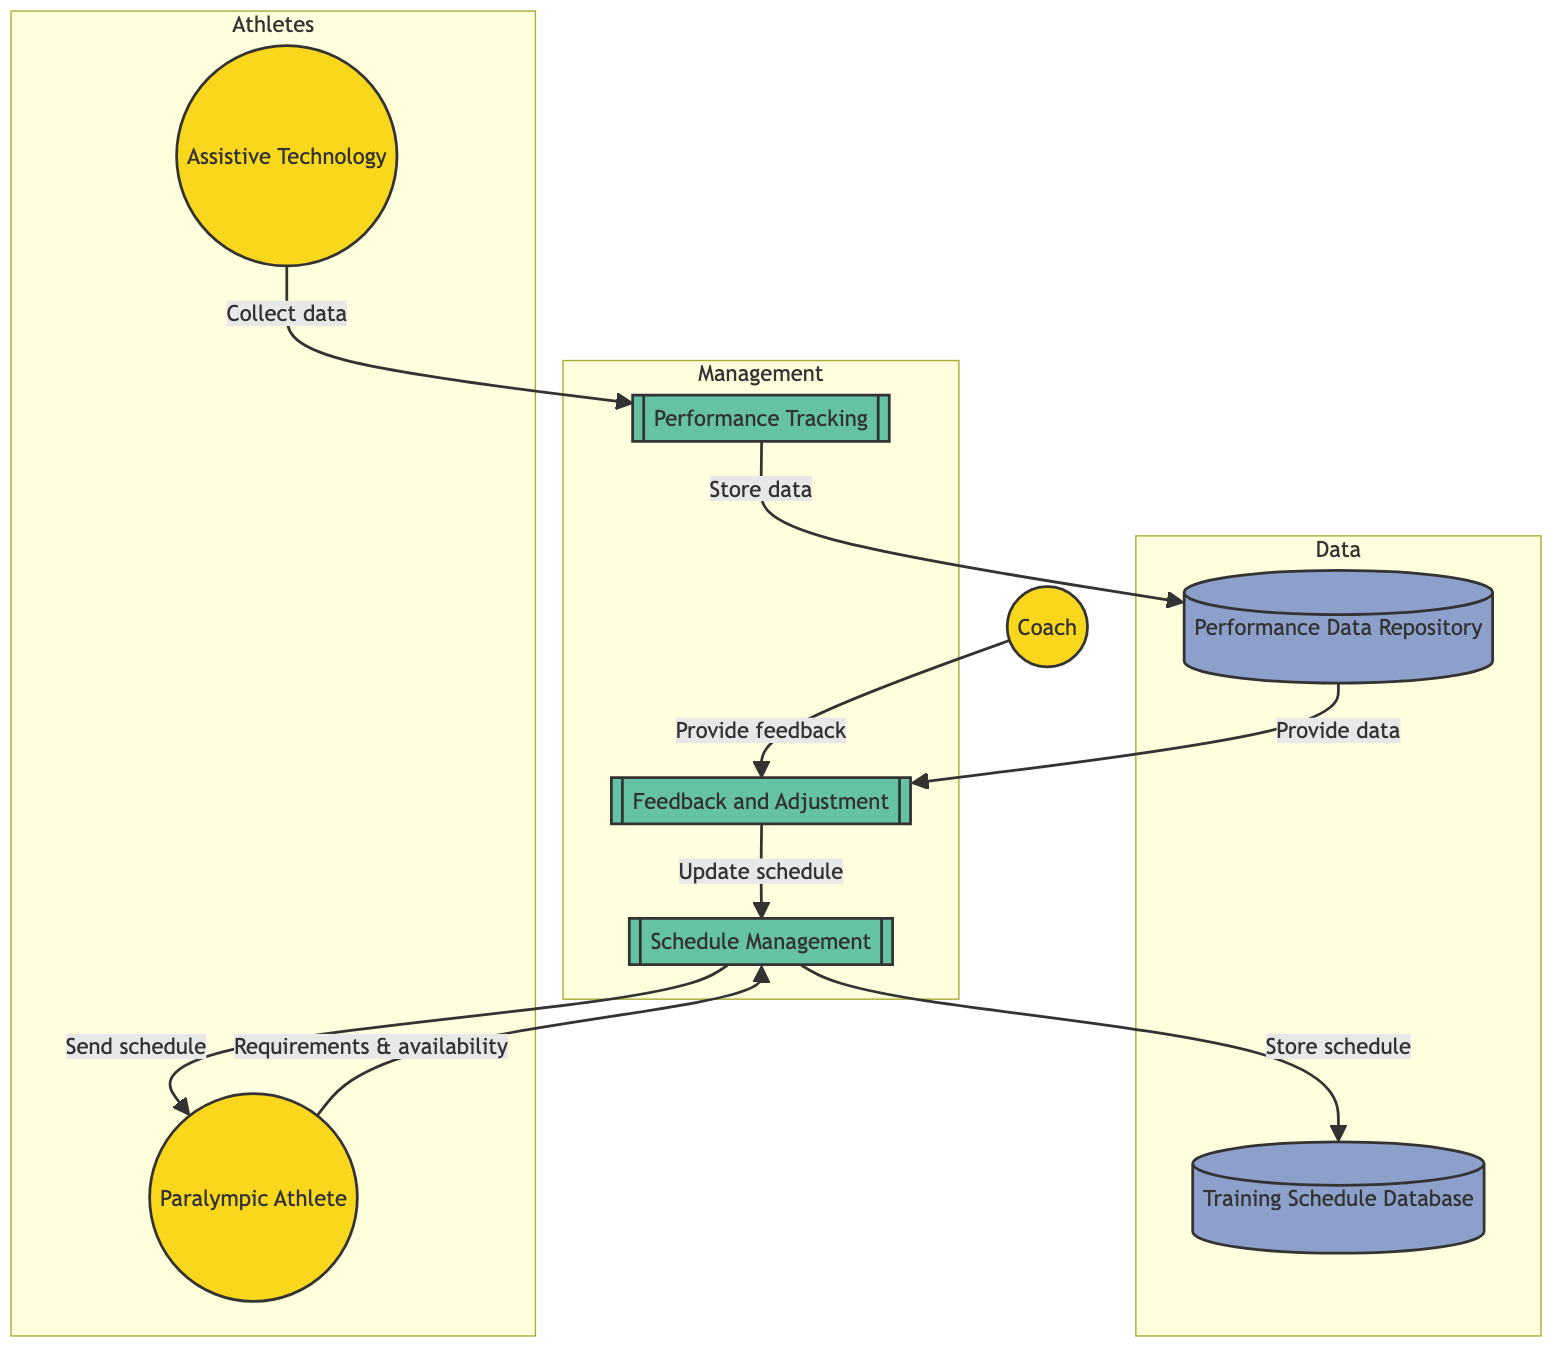What is the first process in the diagram? The first process in the diagram is 'Schedule Management', indicated by the identifier P1 and is positioned at the beginning of the process sequence.
Answer: Schedule Management How many external entities are present in the diagram? By counting the icons labeled as external entities, we can see there are three: Paralympic Athlete, Coach, and Assistive Technology, leading to a total of three external entities in the diagram.
Answer: 3 What does the 'Performance Data Repository' store? The 'Performance Data Repository' is described within the diagram as a datastore that holds records of collected performance data and metrics obtained from training sessions.
Answer: Collected performance data and metrics Which entity provides feedback to adjust the training schedule? According to the diagram, the Coach (labeled as EE2) is indicated as the entity that provides feedback to adjust the training schedule through the designated flow to the Feedback and Adjustment process.
Answer: Coach How does the 'Schedule Management' process update the training schedule? The update to the training schedule occurs when the Feedback and Adjustment process sends updated information back to the Schedule Management process based on performance data and feedback from the coach, forming a loop of continued adjustments and improvements.
Answer: Through Feedback and Adjustment process What is the source of performance data collected during training? The Assistive Technology (labeled as EE3) is the source that collects performance data during training sessions and sends it to the Performance Tracking process for further analysis and storage, enabling effective performance assessment.
Answer: Assistive Technology How does the athlete receive their training schedule? From the diagram, it is clear that after the Schedule Management process updates the training schedule, it sends this newly updated schedule back to the Paralympic Athlete, thus ensuring they have the latest training information.
Answer: Sends training schedule to athlete What is the data store linked to performance tracking? The data store linked to performance tracking is labeled as 'Performance Data Repository' (DS2) and is responsible for storing the data collected from the Performance Tracking process.
Answer: Performance Data Repository 